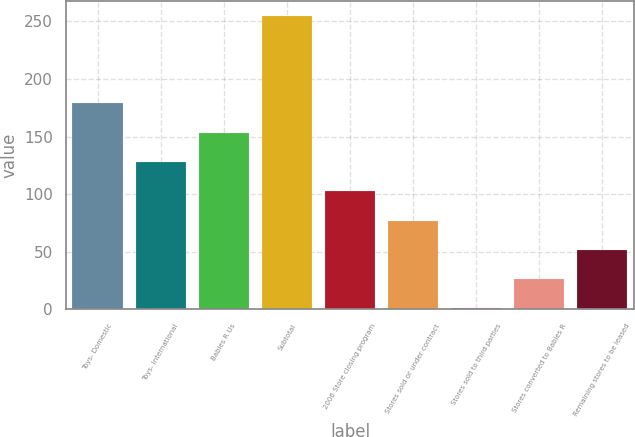Convert chart. <chart><loc_0><loc_0><loc_500><loc_500><bar_chart><fcel>Toys- Domestic<fcel>Toys- International<fcel>Babies R Us<fcel>Subtotal<fcel>2006 Store closing program<fcel>Stores sold or under contract<fcel>Stores sold to third parties<fcel>Stores converted to Babies R<fcel>Remaining stores to be leased<nl><fcel>178.8<fcel>128<fcel>153.4<fcel>255<fcel>102.6<fcel>77.2<fcel>1<fcel>26.4<fcel>51.8<nl></chart> 